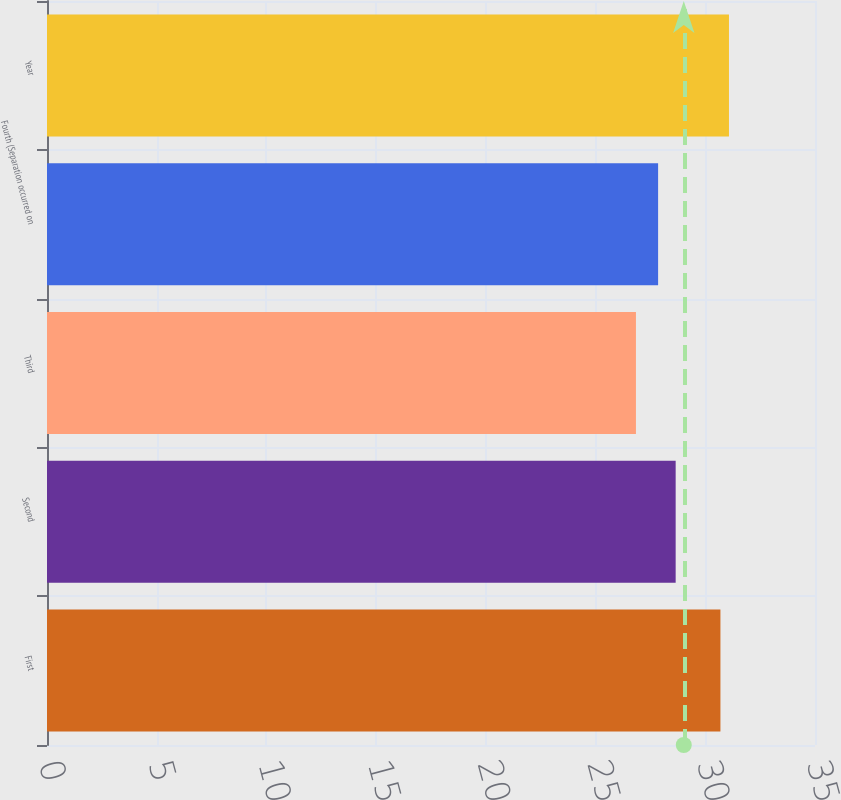Convert chart to OTSL. <chart><loc_0><loc_0><loc_500><loc_500><bar_chart><fcel>First<fcel>Second<fcel>Third<fcel>Fourth (Separation occurred on<fcel>Year<nl><fcel>30.69<fcel>28.65<fcel>26.84<fcel>27.85<fcel>31.08<nl></chart> 